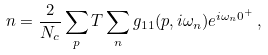Convert formula to latex. <formula><loc_0><loc_0><loc_500><loc_500>n = \frac { 2 } { N _ { c } } \sum _ { p } T \sum _ { n } g _ { 1 1 } ( { p } , i \omega _ { n } ) e ^ { i \omega _ { n } 0 ^ { + } } \, ,</formula> 